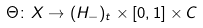Convert formula to latex. <formula><loc_0><loc_0><loc_500><loc_500>\Theta \colon X \to ( H _ { - } ) _ { t } \times [ 0 , 1 ] \times C</formula> 